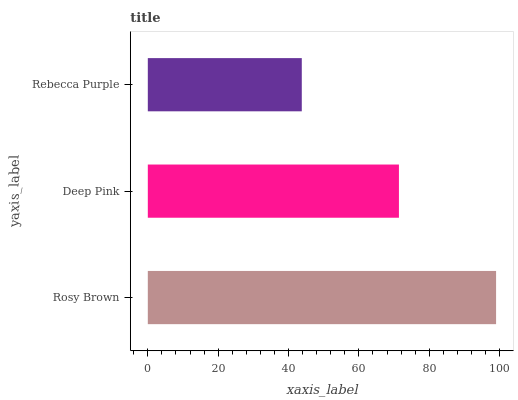Is Rebecca Purple the minimum?
Answer yes or no. Yes. Is Rosy Brown the maximum?
Answer yes or no. Yes. Is Deep Pink the minimum?
Answer yes or no. No. Is Deep Pink the maximum?
Answer yes or no. No. Is Rosy Brown greater than Deep Pink?
Answer yes or no. Yes. Is Deep Pink less than Rosy Brown?
Answer yes or no. Yes. Is Deep Pink greater than Rosy Brown?
Answer yes or no. No. Is Rosy Brown less than Deep Pink?
Answer yes or no. No. Is Deep Pink the high median?
Answer yes or no. Yes. Is Deep Pink the low median?
Answer yes or no. Yes. Is Rebecca Purple the high median?
Answer yes or no. No. Is Rosy Brown the low median?
Answer yes or no. No. 